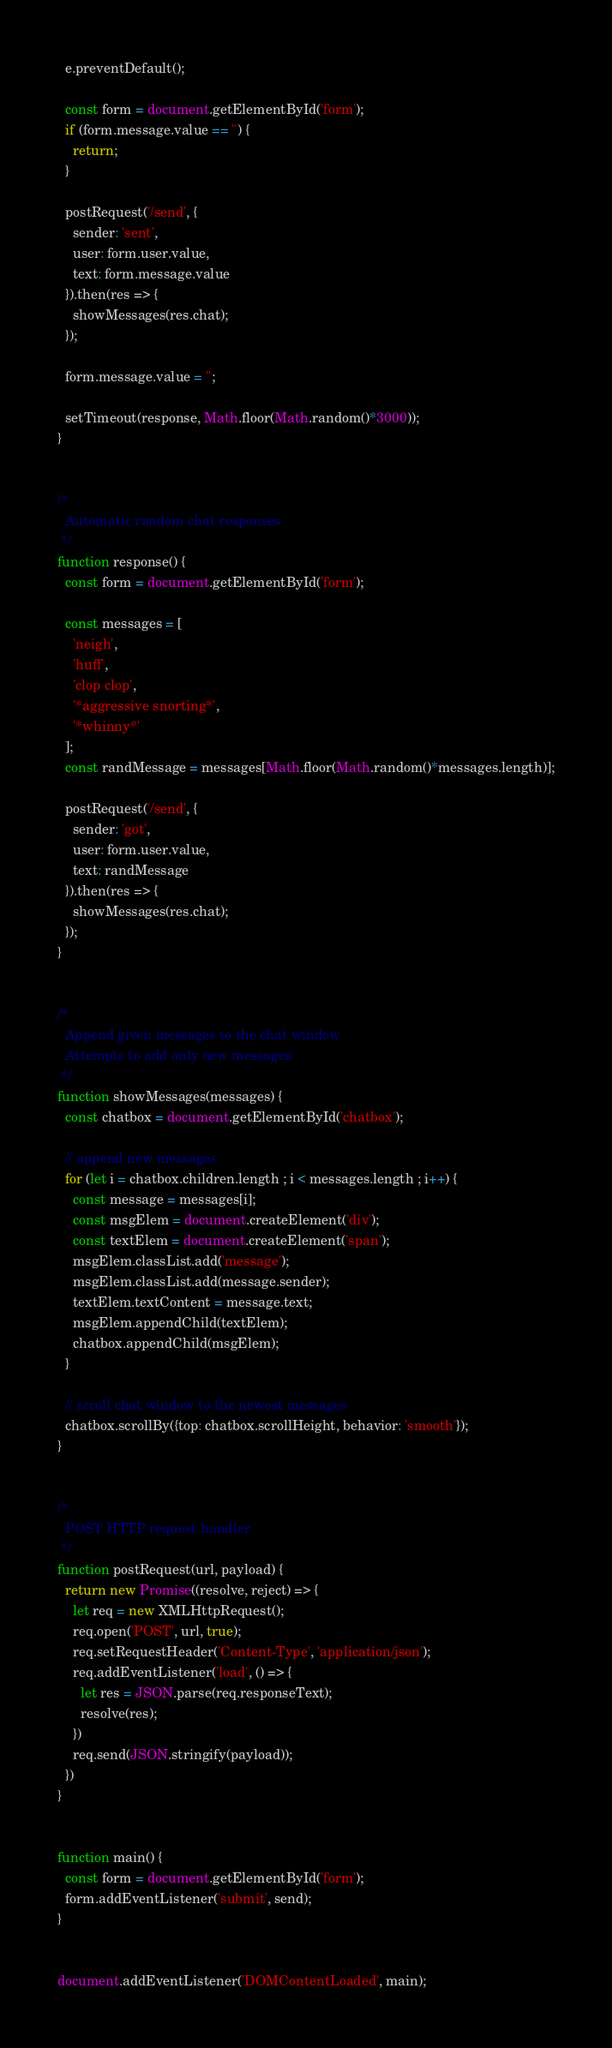<code> <loc_0><loc_0><loc_500><loc_500><_JavaScript_>  e.preventDefault();

  const form = document.getElementById('form');
  if (form.message.value == '') {
    return;
  }

  postRequest('/send', {
    sender: 'sent',
    user: form.user.value,
    text: form.message.value
  }).then(res => {
    showMessages(res.chat);
  });

  form.message.value = '';

  setTimeout(response, Math.floor(Math.random()*3000));
}


/*
  Automatic random chat responses
 */
function response() {
  const form = document.getElementById('form');

  const messages = [
    'neigh',
    'huff',
    'clop clop',
    '*aggressive snorting*',
    '*whinny*'
  ];
  const randMessage = messages[Math.floor(Math.random()*messages.length)];

  postRequest('/send', {
    sender: 'got',
    user: form.user.value,
    text: randMessage
  }).then(res => {
    showMessages(res.chat);
  });
}


/*
  Append given messages to the chat window
  Attempts to add only new messages
 */
function showMessages(messages) {
  const chatbox = document.getElementById('chatbox');

  // append new messages
  for (let i = chatbox.children.length ; i < messages.length ; i++) {
    const message = messages[i];
    const msgElem = document.createElement('div');
    const textElem = document.createElement('span');
    msgElem.classList.add('message');
    msgElem.classList.add(message.sender);
    textElem.textContent = message.text;
    msgElem.appendChild(textElem);
    chatbox.appendChild(msgElem);
  }

  // scroll chat window to the newest messages
  chatbox.scrollBy({top: chatbox.scrollHeight, behavior: 'smooth'});
}


/*
  POST HTTP request handler
 */
function postRequest(url, payload) {
  return new Promise((resolve, reject) => {
    let req = new XMLHttpRequest();
    req.open('POST', url, true);
    req.setRequestHeader('Content-Type', 'application/json');
    req.addEventListener('load', () => {
      let res = JSON.parse(req.responseText);
      resolve(res);
    })
    req.send(JSON.stringify(payload));
  })
}


function main() {
  const form = document.getElementById('form');
  form.addEventListener('submit', send);
}


document.addEventListener('DOMContentLoaded', main);</code> 